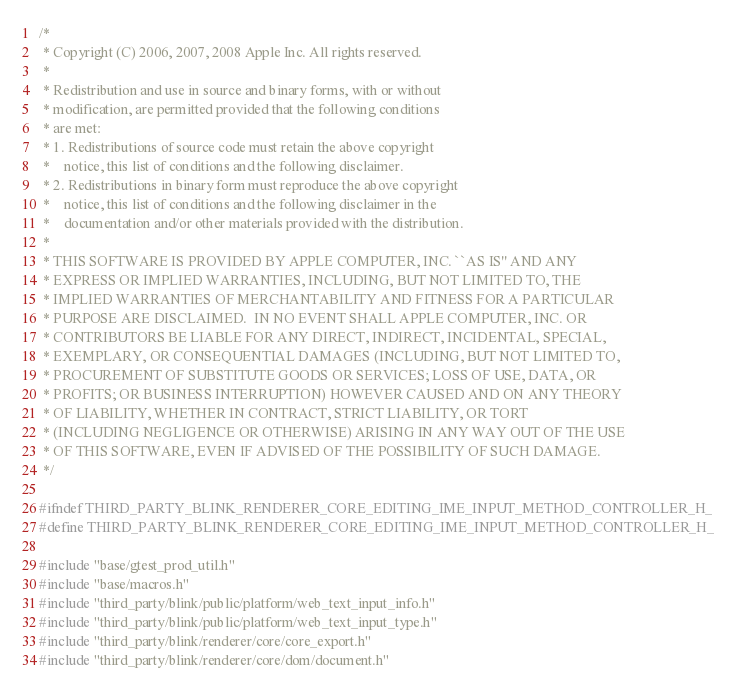Convert code to text. <code><loc_0><loc_0><loc_500><loc_500><_C_>/*
 * Copyright (C) 2006, 2007, 2008 Apple Inc. All rights reserved.
 *
 * Redistribution and use in source and binary forms, with or without
 * modification, are permitted provided that the following conditions
 * are met:
 * 1. Redistributions of source code must retain the above copyright
 *    notice, this list of conditions and the following disclaimer.
 * 2. Redistributions in binary form must reproduce the above copyright
 *    notice, this list of conditions and the following disclaimer in the
 *    documentation and/or other materials provided with the distribution.
 *
 * THIS SOFTWARE IS PROVIDED BY APPLE COMPUTER, INC. ``AS IS'' AND ANY
 * EXPRESS OR IMPLIED WARRANTIES, INCLUDING, BUT NOT LIMITED TO, THE
 * IMPLIED WARRANTIES OF MERCHANTABILITY AND FITNESS FOR A PARTICULAR
 * PURPOSE ARE DISCLAIMED.  IN NO EVENT SHALL APPLE COMPUTER, INC. OR
 * CONTRIBUTORS BE LIABLE FOR ANY DIRECT, INDIRECT, INCIDENTAL, SPECIAL,
 * EXEMPLARY, OR CONSEQUENTIAL DAMAGES (INCLUDING, BUT NOT LIMITED TO,
 * PROCUREMENT OF SUBSTITUTE GOODS OR SERVICES; LOSS OF USE, DATA, OR
 * PROFITS; OR BUSINESS INTERRUPTION) HOWEVER CAUSED AND ON ANY THEORY
 * OF LIABILITY, WHETHER IN CONTRACT, STRICT LIABILITY, OR TORT
 * (INCLUDING NEGLIGENCE OR OTHERWISE) ARISING IN ANY WAY OUT OF THE USE
 * OF THIS SOFTWARE, EVEN IF ADVISED OF THE POSSIBILITY OF SUCH DAMAGE.
 */

#ifndef THIRD_PARTY_BLINK_RENDERER_CORE_EDITING_IME_INPUT_METHOD_CONTROLLER_H_
#define THIRD_PARTY_BLINK_RENDERER_CORE_EDITING_IME_INPUT_METHOD_CONTROLLER_H_

#include "base/gtest_prod_util.h"
#include "base/macros.h"
#include "third_party/blink/public/platform/web_text_input_info.h"
#include "third_party/blink/public/platform/web_text_input_type.h"
#include "third_party/blink/renderer/core/core_export.h"
#include "third_party/blink/renderer/core/dom/document.h"</code> 